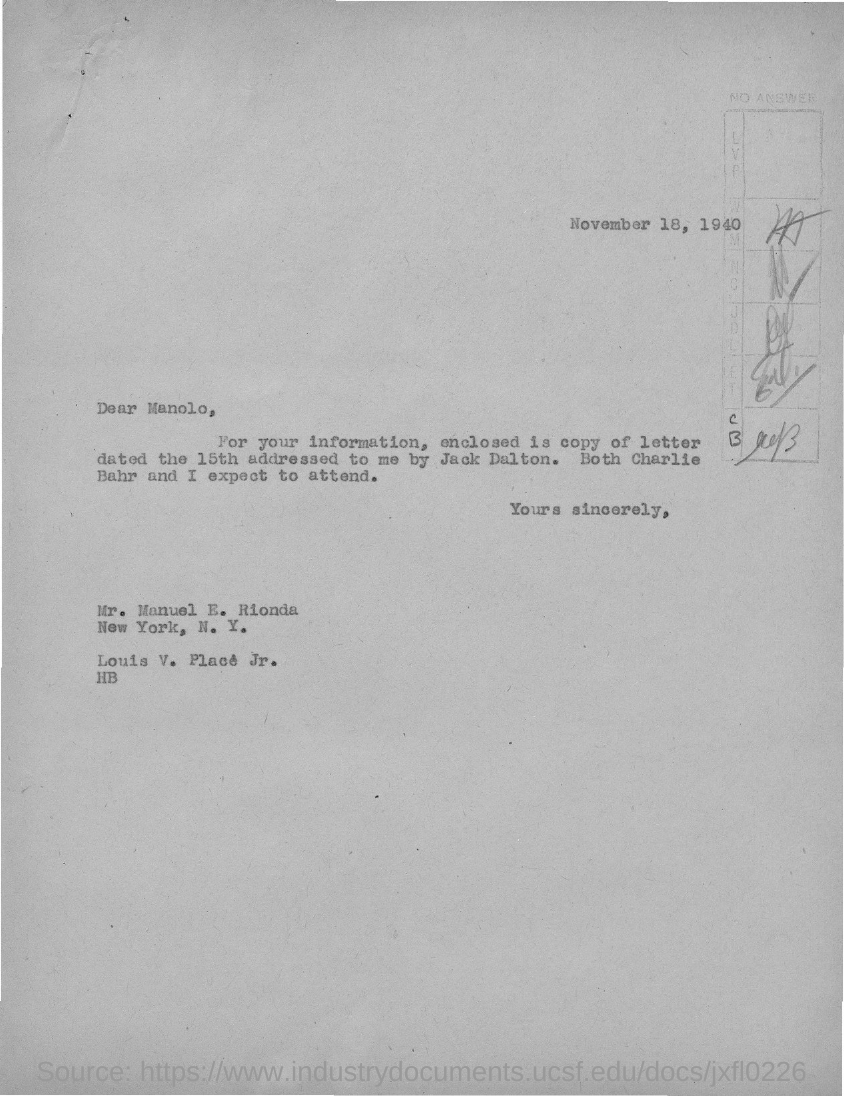Specify some key components in this picture. The letter is addressed to a person named Manolo. The letter was dated November 18, 1940. 